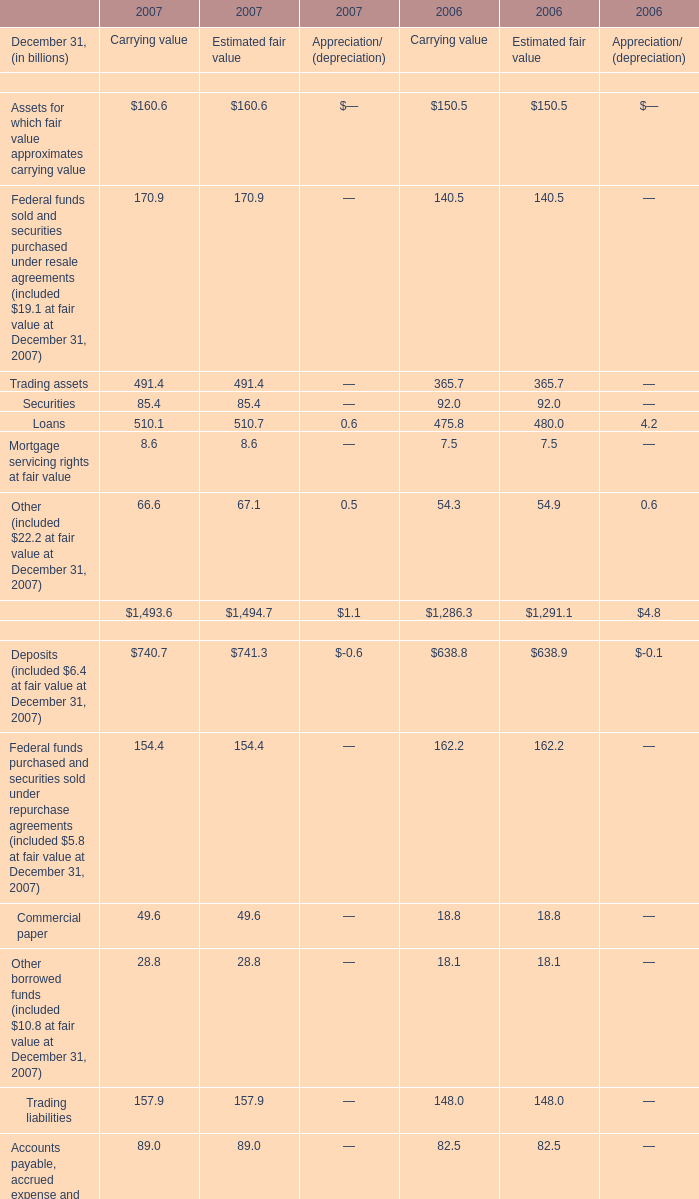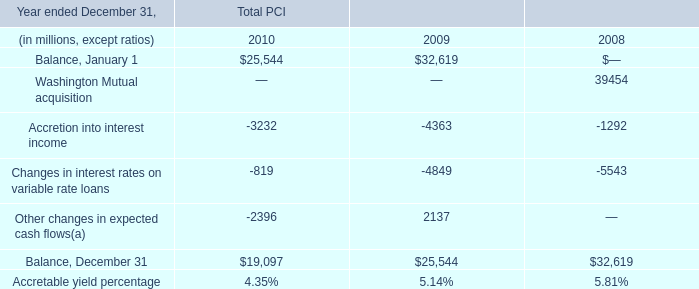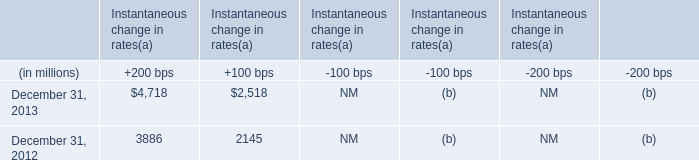What will Loans for Carrying value be like in 2008 if it develops with the same increasing rate as current? (in billion) 
Computations: (510.1 * (1 + ((510.1 - 475.8) / 475.8)))
Answer: 546.87266. 